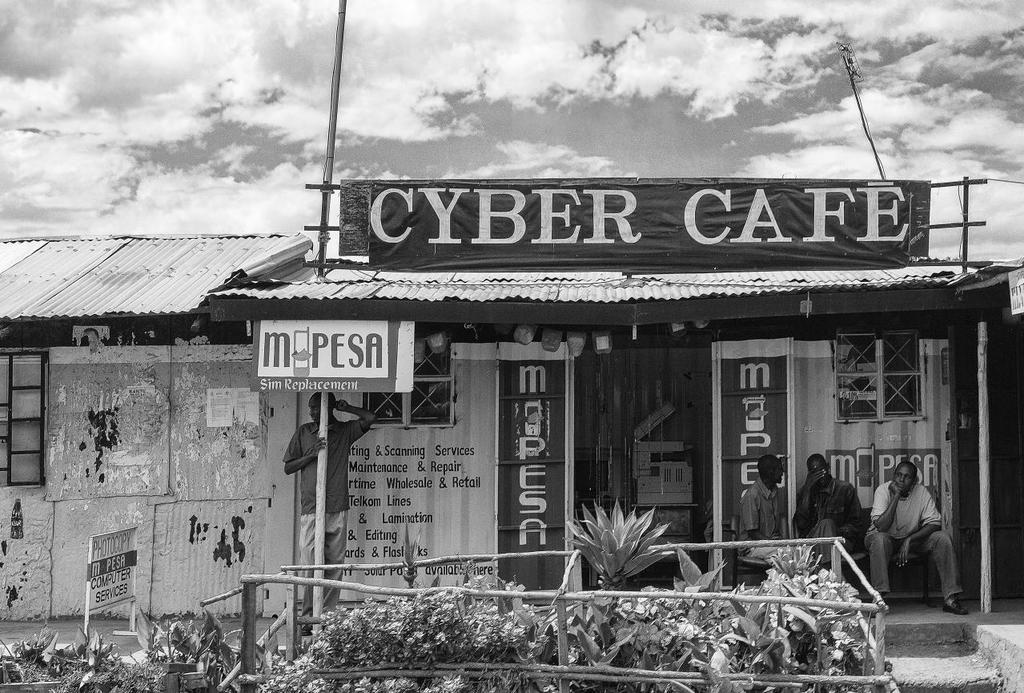Provide a one-sentence caption for the provided image. A black and white photo of a cyber cafe and sim replacement store sits in front of clouds. 